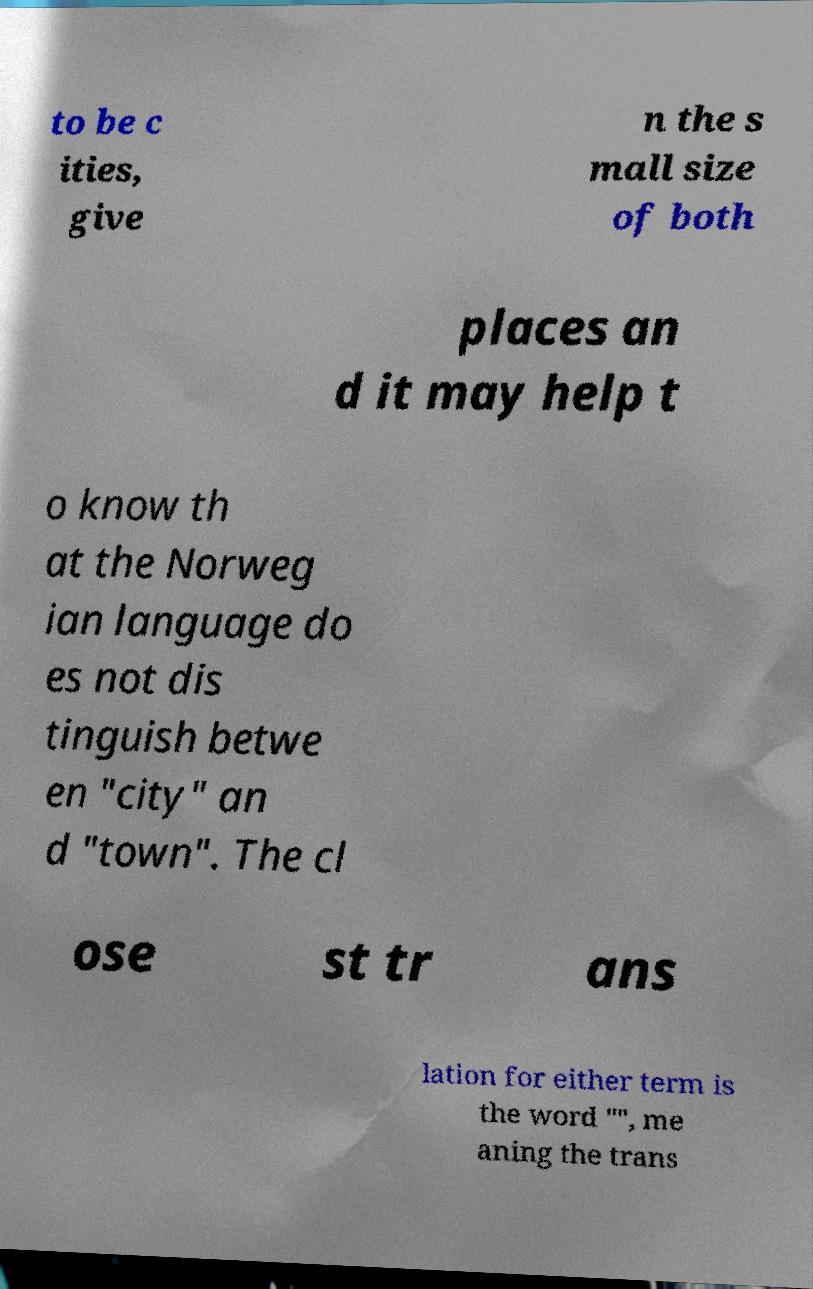Please identify and transcribe the text found in this image. to be c ities, give n the s mall size of both places an d it may help t o know th at the Norweg ian language do es not dis tinguish betwe en "city" an d "town". The cl ose st tr ans lation for either term is the word "", me aning the trans 